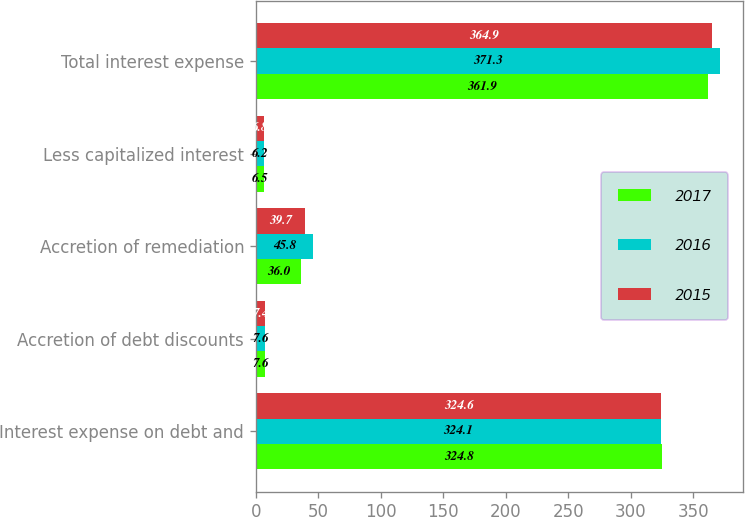Convert chart to OTSL. <chart><loc_0><loc_0><loc_500><loc_500><stacked_bar_chart><ecel><fcel>Interest expense on debt and<fcel>Accretion of debt discounts<fcel>Accretion of remediation<fcel>Less capitalized interest<fcel>Total interest expense<nl><fcel>2017<fcel>324.8<fcel>7.6<fcel>36<fcel>6.5<fcel>361.9<nl><fcel>2016<fcel>324.1<fcel>7.6<fcel>45.8<fcel>6.2<fcel>371.3<nl><fcel>2015<fcel>324.6<fcel>7.4<fcel>39.7<fcel>6.8<fcel>364.9<nl></chart> 